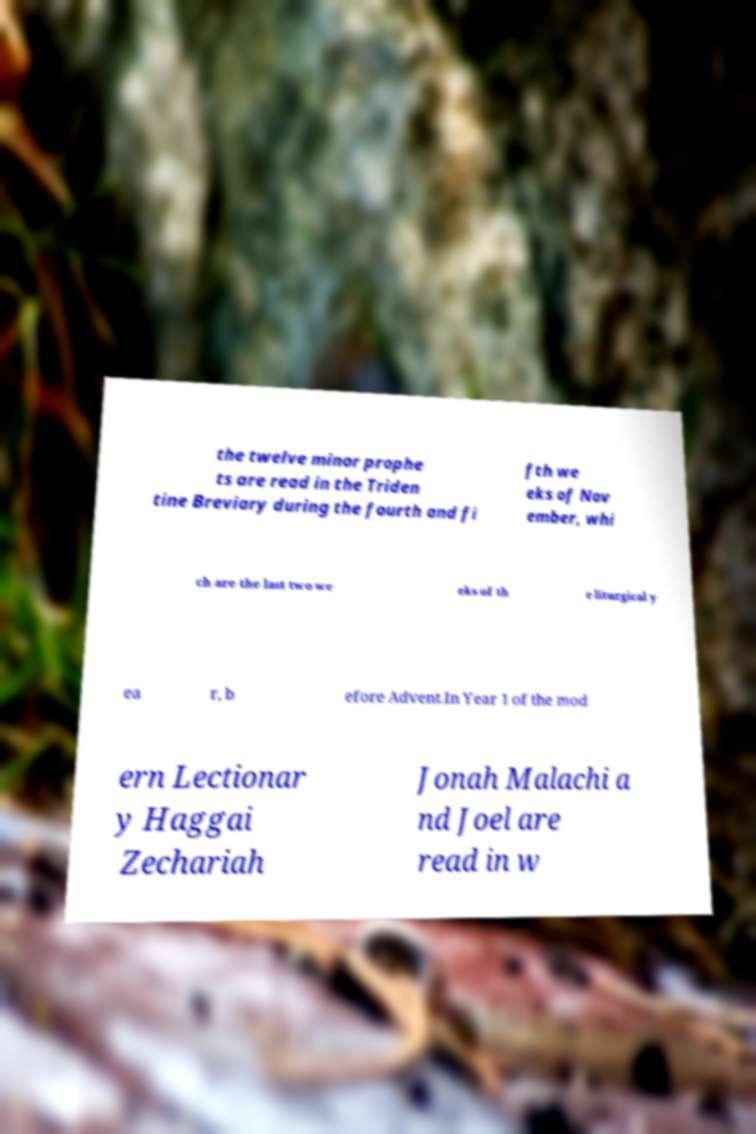Can you read and provide the text displayed in the image?This photo seems to have some interesting text. Can you extract and type it out for me? the twelve minor prophe ts are read in the Triden tine Breviary during the fourth and fi fth we eks of Nov ember, whi ch are the last two we eks of th e liturgical y ea r, b efore Advent.In Year 1 of the mod ern Lectionar y Haggai Zechariah Jonah Malachi a nd Joel are read in w 